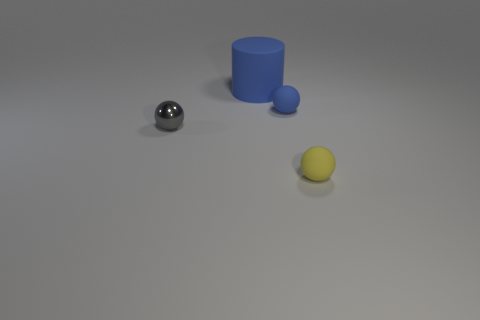Is there any other thing that is the same size as the cylinder?
Keep it short and to the point. No. What number of yellow matte objects are the same shape as the large blue thing?
Keep it short and to the point. 0. What number of objects are large blue matte objects or tiny things that are behind the gray object?
Offer a terse response. 2. There is a big matte cylinder; is it the same color as the tiny sphere on the right side of the blue ball?
Your response must be concise. No. What is the size of the thing that is both behind the small yellow object and to the right of the big cylinder?
Ensure brevity in your answer.  Small. Are there any blue cylinders in front of the small blue ball?
Ensure brevity in your answer.  No. There is a small rubber object in front of the small shiny thing; is there a blue matte ball that is on the right side of it?
Your answer should be compact. No. Is the number of things that are on the left side of the large object the same as the number of large blue cylinders that are left of the gray thing?
Provide a succinct answer. No. What is the color of the other small sphere that is the same material as the blue sphere?
Provide a succinct answer. Yellow. Are there any other tiny yellow cylinders that have the same material as the cylinder?
Offer a very short reply. No. 